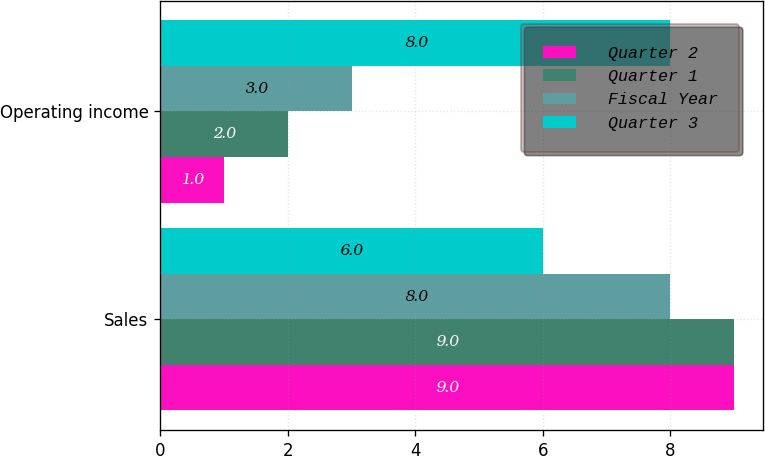<chart> <loc_0><loc_0><loc_500><loc_500><stacked_bar_chart><ecel><fcel>Sales<fcel>Operating income<nl><fcel>Quarter 2<fcel>9<fcel>1<nl><fcel>Quarter 1<fcel>9<fcel>2<nl><fcel>Fiscal Year<fcel>8<fcel>3<nl><fcel>Quarter 3<fcel>6<fcel>8<nl></chart> 